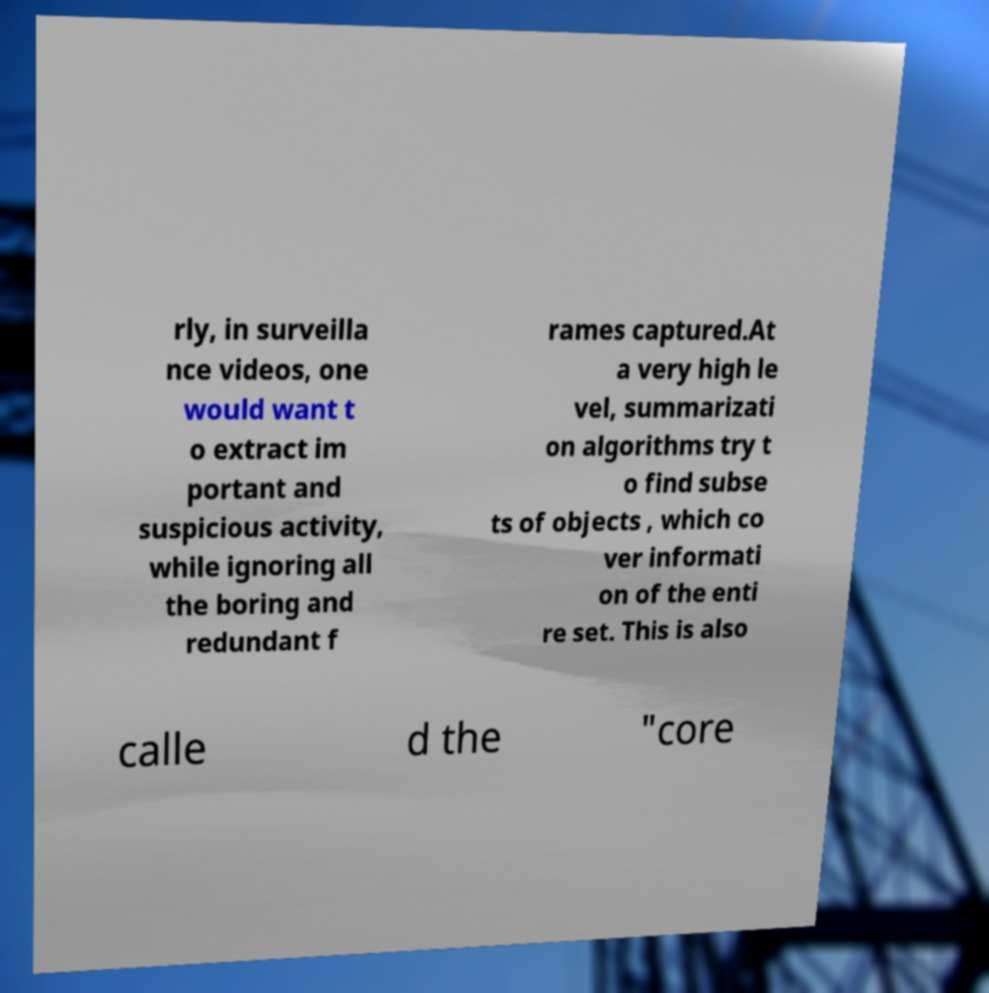Could you assist in decoding the text presented in this image and type it out clearly? rly, in surveilla nce videos, one would want t o extract im portant and suspicious activity, while ignoring all the boring and redundant f rames captured.At a very high le vel, summarizati on algorithms try t o find subse ts of objects , which co ver informati on of the enti re set. This is also calle d the "core 